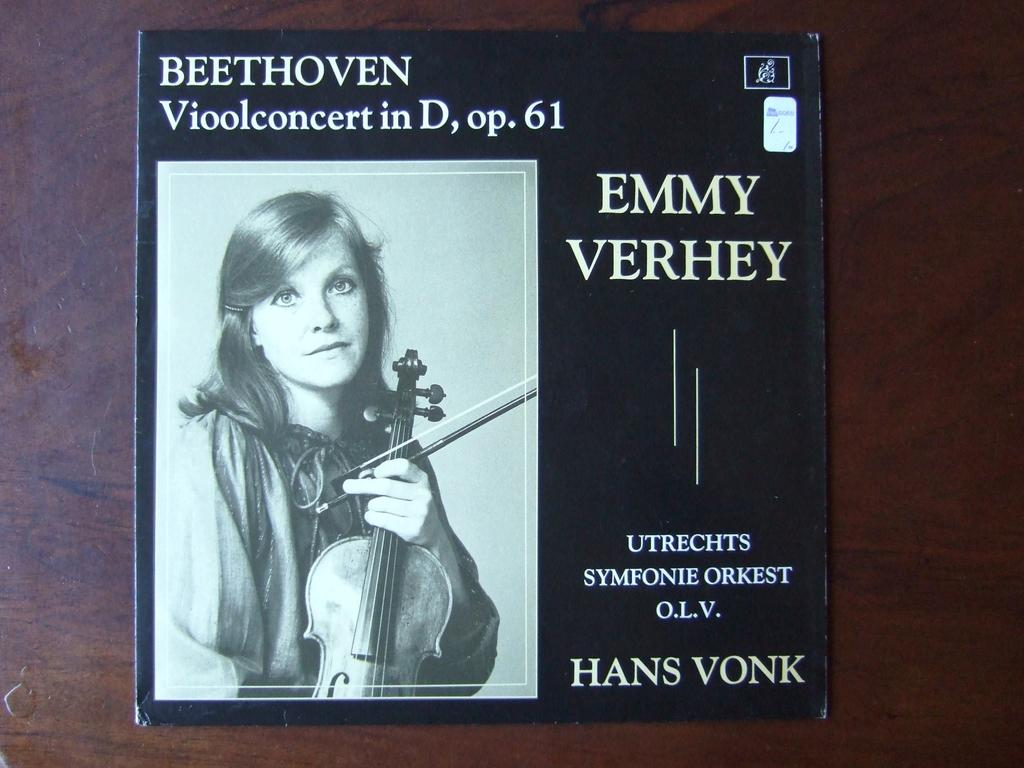What object is visible in the image? There is a book in the image. Where is the book located? The book is placed on a table. What can be seen on the cover of the book? The cover of the book has text and features a woman holding a violin. Can you find the map on the back of the book? There is no map present on the book in the image. 